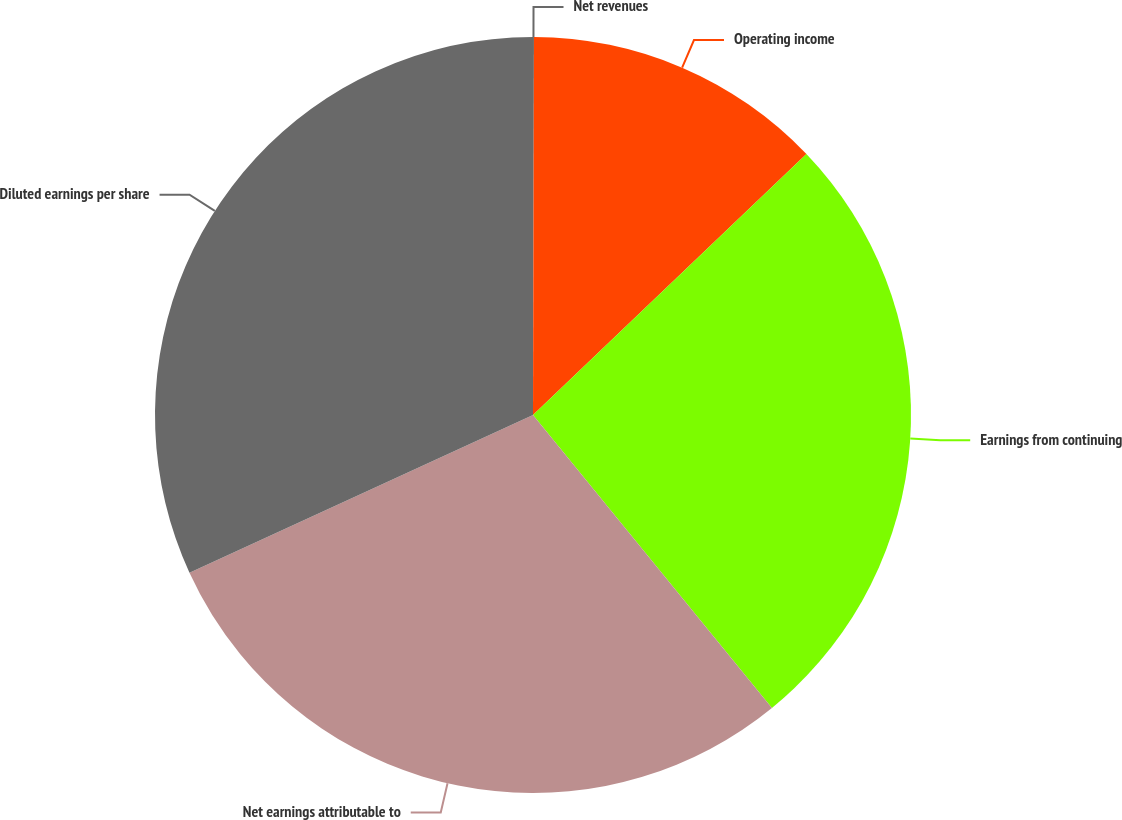Convert chart. <chart><loc_0><loc_0><loc_500><loc_500><pie_chart><fcel>Net revenues<fcel>Operating income<fcel>Earnings from continuing<fcel>Net earnings attributable to<fcel>Diluted earnings per share<nl><fcel>0.04%<fcel>12.83%<fcel>26.24%<fcel>29.04%<fcel>31.85%<nl></chart> 